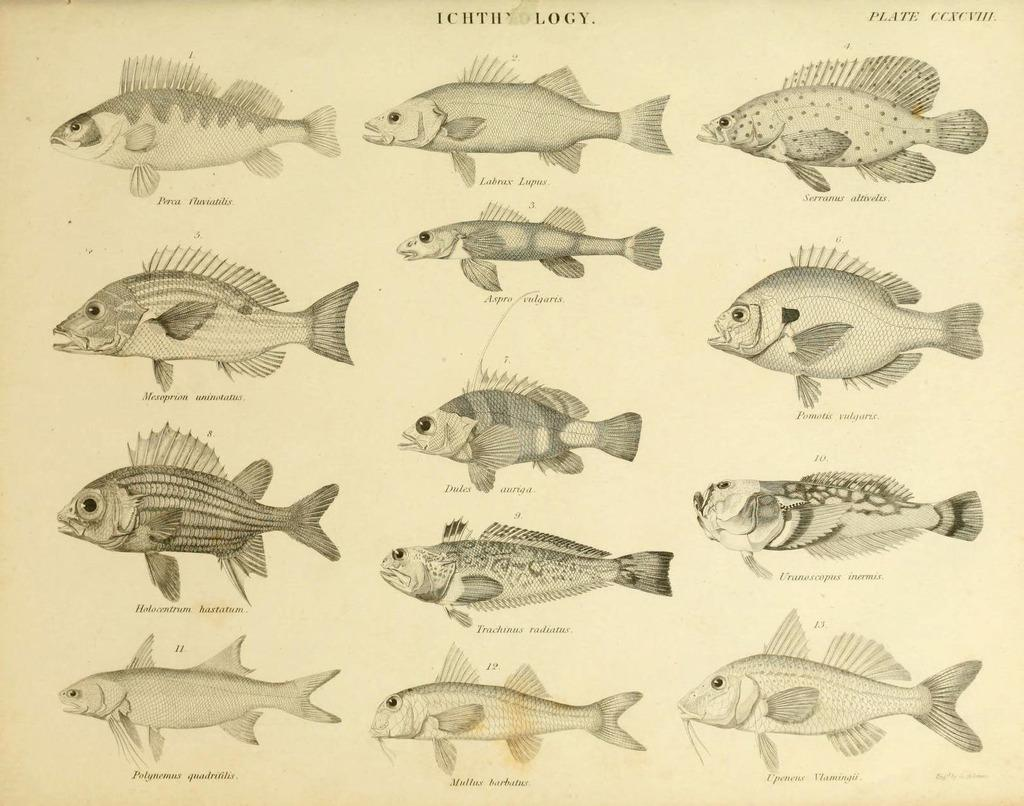What is the main subject of the image? The main subject of the image is a photo. What can be seen in the photo? The photo contains fishes. What type of skirt is visible in the image? There is no skirt present in the image; it features a photo containing fishes. What country is depicted in the image? The image does not depict a country; it features a photo containing fishes. 